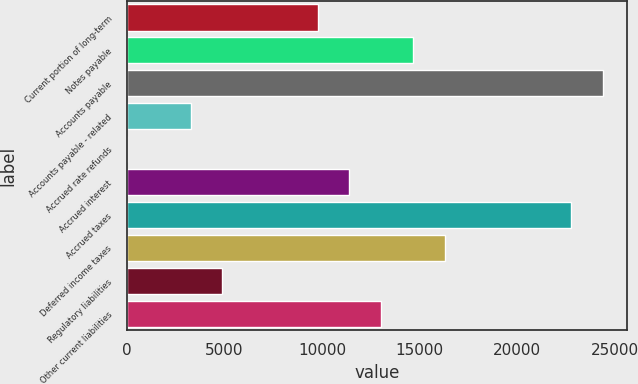<chart> <loc_0><loc_0><loc_500><loc_500><bar_chart><fcel>Current portion of long-term<fcel>Notes payable<fcel>Accounts payable<fcel>Accounts payable - related<fcel>Accrued rate refunds<fcel>Accrued interest<fcel>Accrued taxes<fcel>Deferred income taxes<fcel>Regulatory liabilities<fcel>Other current liabilities<nl><fcel>9767.4<fcel>14648.1<fcel>24409.5<fcel>3259.8<fcel>6<fcel>11394.3<fcel>22782.6<fcel>16275<fcel>4886.7<fcel>13021.2<nl></chart> 